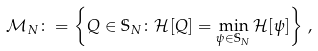Convert formula to latex. <formula><loc_0><loc_0><loc_500><loc_500>\mathcal { M } _ { N } \colon = \left \{ Q \in \mathbb { S } _ { N } \colon \mathcal { H } [ Q ] = \min _ { \psi \in \mathbb { S } _ { N } } \mathcal { H } [ \psi ] \right \} \, ,</formula> 